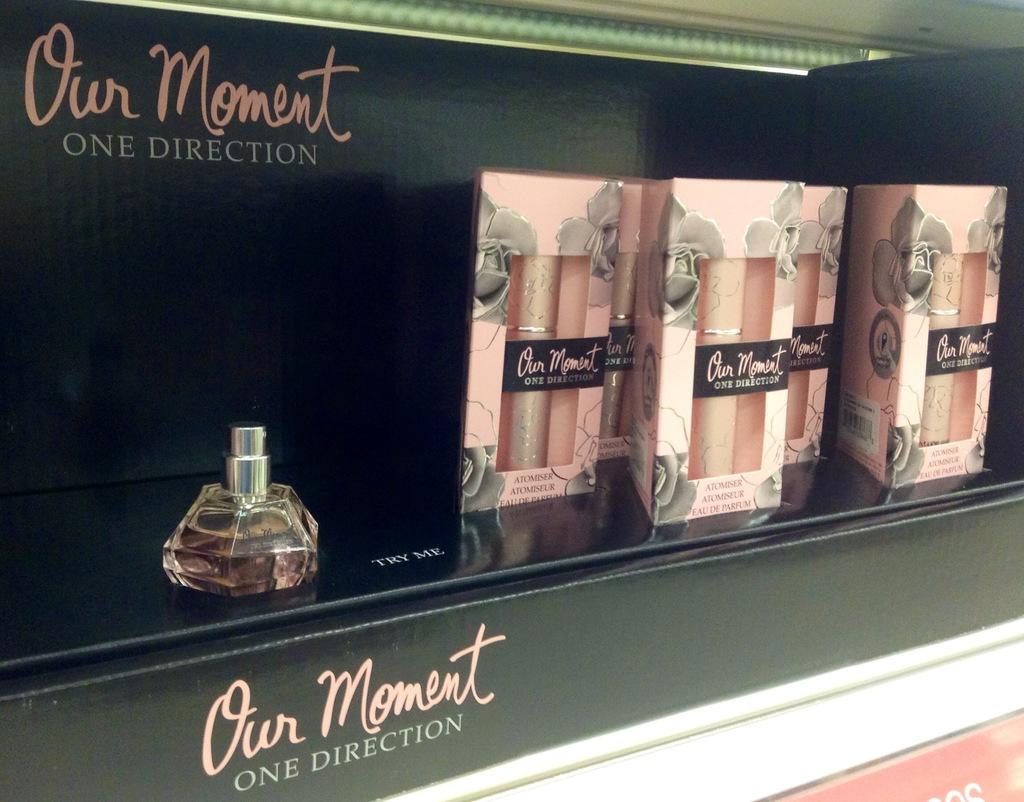<image>
Write a terse but informative summary of the picture. A display of Our Moment perfume by one direction. 